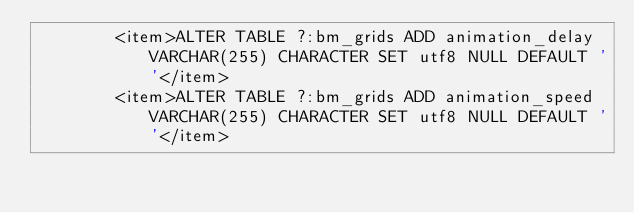Convert code to text. <code><loc_0><loc_0><loc_500><loc_500><_XML_>        <item>ALTER TABLE ?:bm_grids ADD animation_delay VARCHAR(255) CHARACTER SET utf8 NULL DEFAULT ''</item>
        <item>ALTER TABLE ?:bm_grids ADD animation_speed VARCHAR(255) CHARACTER SET utf8 NULL DEFAULT ''</item></code> 